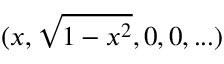<formula> <loc_0><loc_0><loc_500><loc_500>( x , \sqrt { 1 - x ^ { 2 } } , 0 , 0 , \dots )</formula> 